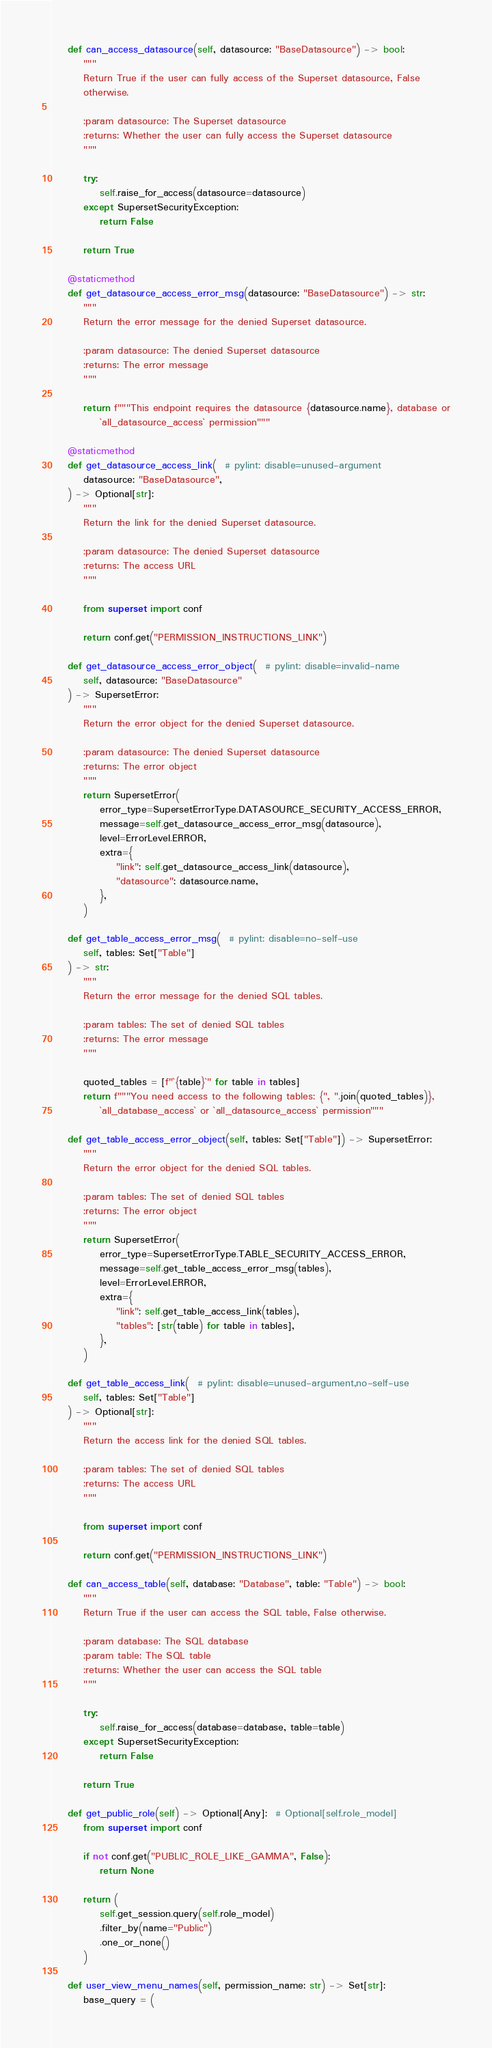<code> <loc_0><loc_0><loc_500><loc_500><_Python_>    def can_access_datasource(self, datasource: "BaseDatasource") -> bool:
        """
        Return True if the user can fully access of the Superset datasource, False
        otherwise.

        :param datasource: The Superset datasource
        :returns: Whether the user can fully access the Superset datasource
        """

        try:
            self.raise_for_access(datasource=datasource)
        except SupersetSecurityException:
            return False

        return True

    @staticmethod
    def get_datasource_access_error_msg(datasource: "BaseDatasource") -> str:
        """
        Return the error message for the denied Superset datasource.

        :param datasource: The denied Superset datasource
        :returns: The error message
        """

        return f"""This endpoint requires the datasource {datasource.name}, database or
            `all_datasource_access` permission"""

    @staticmethod
    def get_datasource_access_link(  # pylint: disable=unused-argument
        datasource: "BaseDatasource",
    ) -> Optional[str]:
        """
        Return the link for the denied Superset datasource.

        :param datasource: The denied Superset datasource
        :returns: The access URL
        """

        from superset import conf

        return conf.get("PERMISSION_INSTRUCTIONS_LINK")

    def get_datasource_access_error_object(  # pylint: disable=invalid-name
        self, datasource: "BaseDatasource"
    ) -> SupersetError:
        """
        Return the error object for the denied Superset datasource.

        :param datasource: The denied Superset datasource
        :returns: The error object
        """
        return SupersetError(
            error_type=SupersetErrorType.DATASOURCE_SECURITY_ACCESS_ERROR,
            message=self.get_datasource_access_error_msg(datasource),
            level=ErrorLevel.ERROR,
            extra={
                "link": self.get_datasource_access_link(datasource),
                "datasource": datasource.name,
            },
        )

    def get_table_access_error_msg(  # pylint: disable=no-self-use
        self, tables: Set["Table"]
    ) -> str:
        """
        Return the error message for the denied SQL tables.

        :param tables: The set of denied SQL tables
        :returns: The error message
        """

        quoted_tables = [f"`{table}`" for table in tables]
        return f"""You need access to the following tables: {", ".join(quoted_tables)},
            `all_database_access` or `all_datasource_access` permission"""

    def get_table_access_error_object(self, tables: Set["Table"]) -> SupersetError:
        """
        Return the error object for the denied SQL tables.

        :param tables: The set of denied SQL tables
        :returns: The error object
        """
        return SupersetError(
            error_type=SupersetErrorType.TABLE_SECURITY_ACCESS_ERROR,
            message=self.get_table_access_error_msg(tables),
            level=ErrorLevel.ERROR,
            extra={
                "link": self.get_table_access_link(tables),
                "tables": [str(table) for table in tables],
            },
        )

    def get_table_access_link(  # pylint: disable=unused-argument,no-self-use
        self, tables: Set["Table"]
    ) -> Optional[str]:
        """
        Return the access link for the denied SQL tables.

        :param tables: The set of denied SQL tables
        :returns: The access URL
        """

        from superset import conf

        return conf.get("PERMISSION_INSTRUCTIONS_LINK")

    def can_access_table(self, database: "Database", table: "Table") -> bool:
        """
        Return True if the user can access the SQL table, False otherwise.

        :param database: The SQL database
        :param table: The SQL table
        :returns: Whether the user can access the SQL table
        """

        try:
            self.raise_for_access(database=database, table=table)
        except SupersetSecurityException:
            return False

        return True

    def get_public_role(self) -> Optional[Any]:  # Optional[self.role_model]
        from superset import conf

        if not conf.get("PUBLIC_ROLE_LIKE_GAMMA", False):
            return None

        return (
            self.get_session.query(self.role_model)
            .filter_by(name="Public")
            .one_or_none()
        )

    def user_view_menu_names(self, permission_name: str) -> Set[str]:
        base_query = (</code> 